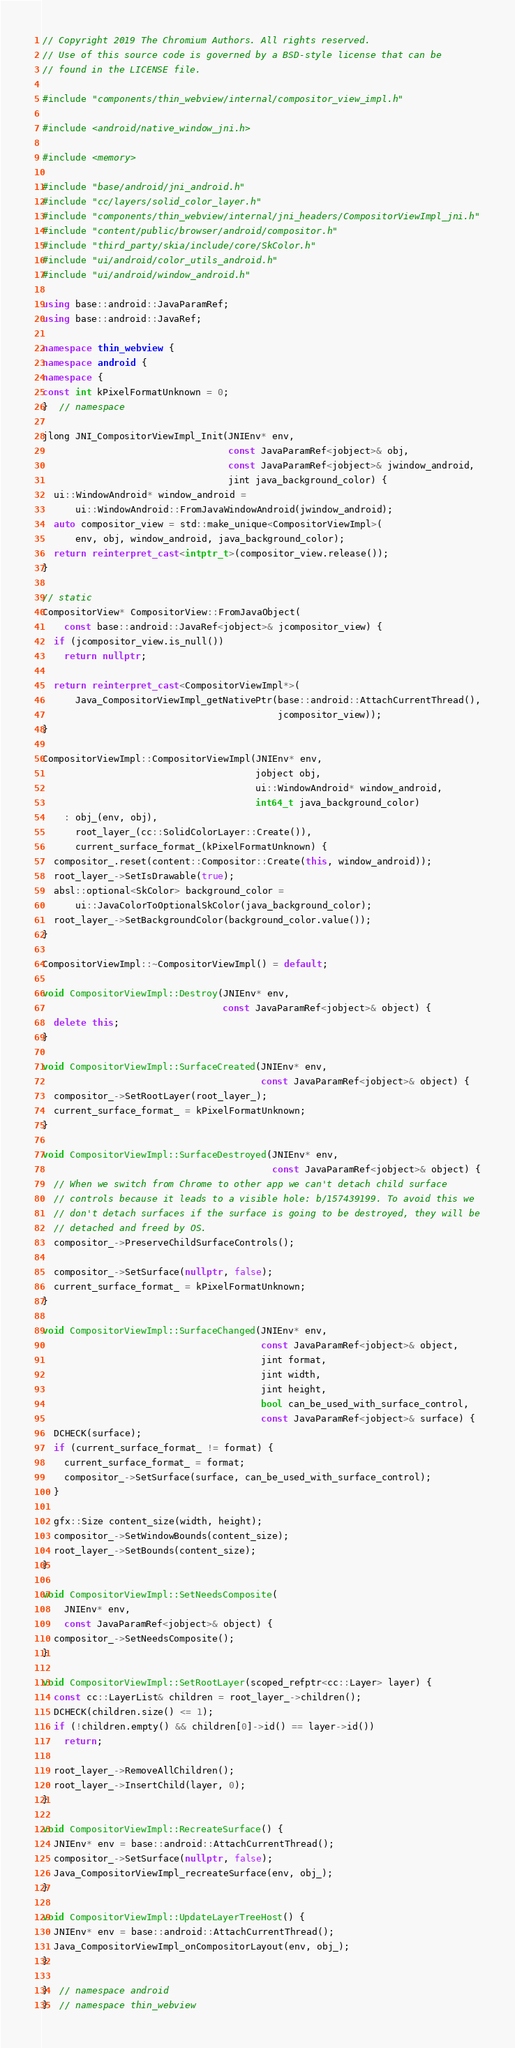<code> <loc_0><loc_0><loc_500><loc_500><_C++_>// Copyright 2019 The Chromium Authors. All rights reserved.
// Use of this source code is governed by a BSD-style license that can be
// found in the LICENSE file.

#include "components/thin_webview/internal/compositor_view_impl.h"

#include <android/native_window_jni.h>

#include <memory>

#include "base/android/jni_android.h"
#include "cc/layers/solid_color_layer.h"
#include "components/thin_webview/internal/jni_headers/CompositorViewImpl_jni.h"
#include "content/public/browser/android/compositor.h"
#include "third_party/skia/include/core/SkColor.h"
#include "ui/android/color_utils_android.h"
#include "ui/android/window_android.h"

using base::android::JavaParamRef;
using base::android::JavaRef;

namespace thin_webview {
namespace android {
namespace {
const int kPixelFormatUnknown = 0;
}  // namespace

jlong JNI_CompositorViewImpl_Init(JNIEnv* env,
                                  const JavaParamRef<jobject>& obj,
                                  const JavaParamRef<jobject>& jwindow_android,
                                  jint java_background_color) {
  ui::WindowAndroid* window_android =
      ui::WindowAndroid::FromJavaWindowAndroid(jwindow_android);
  auto compositor_view = std::make_unique<CompositorViewImpl>(
      env, obj, window_android, java_background_color);
  return reinterpret_cast<intptr_t>(compositor_view.release());
}

// static
CompositorView* CompositorView::FromJavaObject(
    const base::android::JavaRef<jobject>& jcompositor_view) {
  if (jcompositor_view.is_null())
    return nullptr;

  return reinterpret_cast<CompositorViewImpl*>(
      Java_CompositorViewImpl_getNativePtr(base::android::AttachCurrentThread(),
                                           jcompositor_view));
}

CompositorViewImpl::CompositorViewImpl(JNIEnv* env,
                                       jobject obj,
                                       ui::WindowAndroid* window_android,
                                       int64_t java_background_color)
    : obj_(env, obj),
      root_layer_(cc::SolidColorLayer::Create()),
      current_surface_format_(kPixelFormatUnknown) {
  compositor_.reset(content::Compositor::Create(this, window_android));
  root_layer_->SetIsDrawable(true);
  absl::optional<SkColor> background_color =
      ui::JavaColorToOptionalSkColor(java_background_color);
  root_layer_->SetBackgroundColor(background_color.value());
}

CompositorViewImpl::~CompositorViewImpl() = default;

void CompositorViewImpl::Destroy(JNIEnv* env,
                                 const JavaParamRef<jobject>& object) {
  delete this;
}

void CompositorViewImpl::SurfaceCreated(JNIEnv* env,
                                        const JavaParamRef<jobject>& object) {
  compositor_->SetRootLayer(root_layer_);
  current_surface_format_ = kPixelFormatUnknown;
}

void CompositorViewImpl::SurfaceDestroyed(JNIEnv* env,
                                          const JavaParamRef<jobject>& object) {
  // When we switch from Chrome to other app we can't detach child surface
  // controls because it leads to a visible hole: b/157439199. To avoid this we
  // don't detach surfaces if the surface is going to be destroyed, they will be
  // detached and freed by OS.
  compositor_->PreserveChildSurfaceControls();

  compositor_->SetSurface(nullptr, false);
  current_surface_format_ = kPixelFormatUnknown;
}

void CompositorViewImpl::SurfaceChanged(JNIEnv* env,
                                        const JavaParamRef<jobject>& object,
                                        jint format,
                                        jint width,
                                        jint height,
                                        bool can_be_used_with_surface_control,
                                        const JavaParamRef<jobject>& surface) {
  DCHECK(surface);
  if (current_surface_format_ != format) {
    current_surface_format_ = format;
    compositor_->SetSurface(surface, can_be_used_with_surface_control);
  }

  gfx::Size content_size(width, height);
  compositor_->SetWindowBounds(content_size);
  root_layer_->SetBounds(content_size);
}

void CompositorViewImpl::SetNeedsComposite(
    JNIEnv* env,
    const JavaParamRef<jobject>& object) {
  compositor_->SetNeedsComposite();
}

void CompositorViewImpl::SetRootLayer(scoped_refptr<cc::Layer> layer) {
  const cc::LayerList& children = root_layer_->children();
  DCHECK(children.size() <= 1);
  if (!children.empty() && children[0]->id() == layer->id())
    return;

  root_layer_->RemoveAllChildren();
  root_layer_->InsertChild(layer, 0);
}

void CompositorViewImpl::RecreateSurface() {
  JNIEnv* env = base::android::AttachCurrentThread();
  compositor_->SetSurface(nullptr, false);
  Java_CompositorViewImpl_recreateSurface(env, obj_);
}

void CompositorViewImpl::UpdateLayerTreeHost() {
  JNIEnv* env = base::android::AttachCurrentThread();
  Java_CompositorViewImpl_onCompositorLayout(env, obj_);
}

}  // namespace android
}  // namespace thin_webview
</code> 